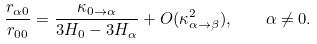Convert formula to latex. <formula><loc_0><loc_0><loc_500><loc_500>\frac { r _ { \alpha 0 } } { r _ { 0 0 } } = \frac { \kappa _ { 0 \rightarrow \alpha } } { 3 H _ { 0 } - 3 H _ { \alpha } } + O ( \kappa _ { \alpha \rightarrow \beta } ^ { 2 } ) , \quad \alpha \neq 0 .</formula> 